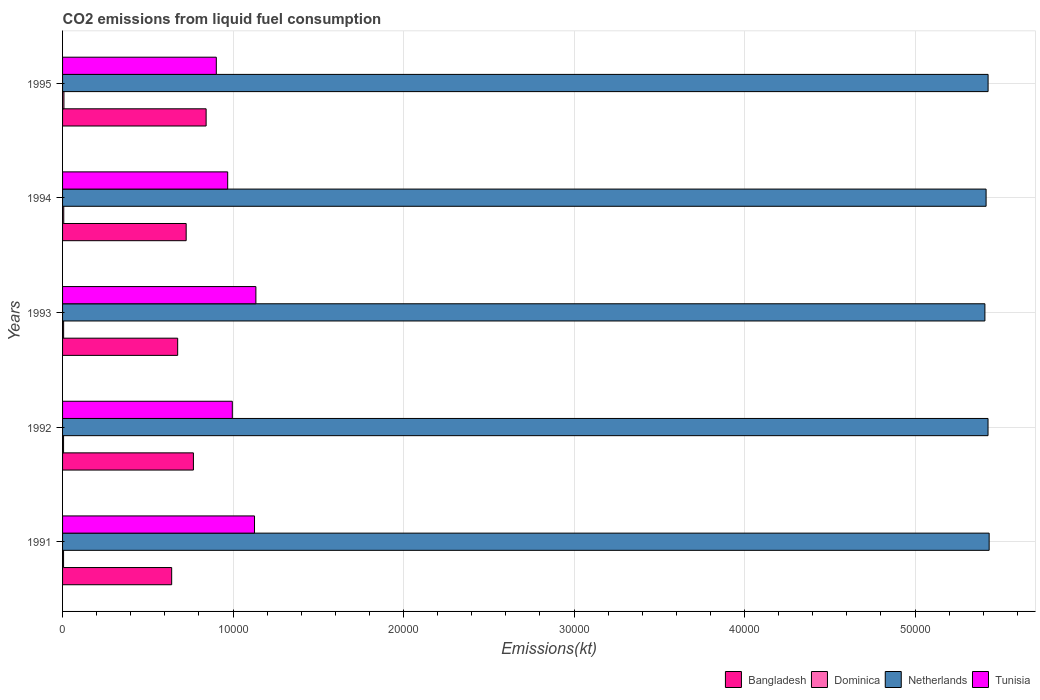How many different coloured bars are there?
Offer a very short reply. 4. Are the number of bars on each tick of the Y-axis equal?
Provide a succinct answer. Yes. What is the label of the 1st group of bars from the top?
Offer a terse response. 1995. What is the amount of CO2 emitted in Netherlands in 1992?
Your answer should be compact. 5.43e+04. Across all years, what is the maximum amount of CO2 emitted in Bangladesh?
Provide a succinct answer. 8419.43. Across all years, what is the minimum amount of CO2 emitted in Bangladesh?
Make the answer very short. 6398.91. What is the total amount of CO2 emitted in Dominica in the graph?
Provide a short and direct response. 330.03. What is the difference between the amount of CO2 emitted in Netherlands in 1991 and that in 1993?
Your answer should be compact. 249.36. What is the difference between the amount of CO2 emitted in Netherlands in 1994 and the amount of CO2 emitted in Tunisia in 1993?
Your answer should be very brief. 4.28e+04. What is the average amount of CO2 emitted in Netherlands per year?
Make the answer very short. 5.42e+04. In the year 1993, what is the difference between the amount of CO2 emitted in Bangladesh and amount of CO2 emitted in Netherlands?
Make the answer very short. -4.73e+04. In how many years, is the amount of CO2 emitted in Dominica greater than 4000 kt?
Ensure brevity in your answer.  0. What is the ratio of the amount of CO2 emitted in Tunisia in 1992 to that in 1995?
Provide a short and direct response. 1.1. Is the amount of CO2 emitted in Netherlands in 1993 less than that in 1994?
Your answer should be very brief. Yes. Is the difference between the amount of CO2 emitted in Bangladesh in 1993 and 1994 greater than the difference between the amount of CO2 emitted in Netherlands in 1993 and 1994?
Your answer should be very brief. No. What is the difference between the highest and the second highest amount of CO2 emitted in Dominica?
Provide a short and direct response. 11. What is the difference between the highest and the lowest amount of CO2 emitted in Bangladesh?
Ensure brevity in your answer.  2020.52. Is it the case that in every year, the sum of the amount of CO2 emitted in Bangladesh and amount of CO2 emitted in Tunisia is greater than the sum of amount of CO2 emitted in Dominica and amount of CO2 emitted in Netherlands?
Provide a short and direct response. No. What does the 2nd bar from the top in 1991 represents?
Offer a very short reply. Netherlands. What does the 2nd bar from the bottom in 1991 represents?
Make the answer very short. Dominica. Is it the case that in every year, the sum of the amount of CO2 emitted in Tunisia and amount of CO2 emitted in Netherlands is greater than the amount of CO2 emitted in Bangladesh?
Keep it short and to the point. Yes. How many bars are there?
Your answer should be compact. 20. How many years are there in the graph?
Your response must be concise. 5. Are the values on the major ticks of X-axis written in scientific E-notation?
Provide a succinct answer. No. Does the graph contain any zero values?
Your response must be concise. No. Where does the legend appear in the graph?
Make the answer very short. Bottom right. How are the legend labels stacked?
Offer a very short reply. Horizontal. What is the title of the graph?
Keep it short and to the point. CO2 emissions from liquid fuel consumption. Does "Timor-Leste" appear as one of the legend labels in the graph?
Keep it short and to the point. No. What is the label or title of the X-axis?
Make the answer very short. Emissions(kt). What is the Emissions(kt) of Bangladesh in 1991?
Offer a terse response. 6398.91. What is the Emissions(kt) of Dominica in 1991?
Your answer should be compact. 58.67. What is the Emissions(kt) of Netherlands in 1991?
Your response must be concise. 5.43e+04. What is the Emissions(kt) in Tunisia in 1991?
Offer a terse response. 1.13e+04. What is the Emissions(kt) in Bangladesh in 1992?
Keep it short and to the point. 7675.03. What is the Emissions(kt) in Dominica in 1992?
Your answer should be compact. 58.67. What is the Emissions(kt) in Netherlands in 1992?
Give a very brief answer. 5.43e+04. What is the Emissions(kt) of Tunisia in 1992?
Make the answer very short. 9955.91. What is the Emissions(kt) in Bangladesh in 1993?
Ensure brevity in your answer.  6750.95. What is the Emissions(kt) of Dominica in 1993?
Provide a succinct answer. 62.34. What is the Emissions(kt) in Netherlands in 1993?
Offer a very short reply. 5.41e+04. What is the Emissions(kt) of Tunisia in 1993?
Your answer should be compact. 1.13e+04. What is the Emissions(kt) in Bangladesh in 1994?
Your answer should be compact. 7249.66. What is the Emissions(kt) in Dominica in 1994?
Your answer should be very brief. 69.67. What is the Emissions(kt) of Netherlands in 1994?
Give a very brief answer. 5.42e+04. What is the Emissions(kt) in Tunisia in 1994?
Ensure brevity in your answer.  9684.55. What is the Emissions(kt) in Bangladesh in 1995?
Give a very brief answer. 8419.43. What is the Emissions(kt) of Dominica in 1995?
Offer a terse response. 80.67. What is the Emissions(kt) in Netherlands in 1995?
Provide a short and direct response. 5.43e+04. What is the Emissions(kt) in Tunisia in 1995?
Offer a terse response. 9017.15. Across all years, what is the maximum Emissions(kt) of Bangladesh?
Ensure brevity in your answer.  8419.43. Across all years, what is the maximum Emissions(kt) of Dominica?
Ensure brevity in your answer.  80.67. Across all years, what is the maximum Emissions(kt) in Netherlands?
Provide a short and direct response. 5.43e+04. Across all years, what is the maximum Emissions(kt) of Tunisia?
Your response must be concise. 1.13e+04. Across all years, what is the minimum Emissions(kt) in Bangladesh?
Provide a short and direct response. 6398.91. Across all years, what is the minimum Emissions(kt) in Dominica?
Your response must be concise. 58.67. Across all years, what is the minimum Emissions(kt) in Netherlands?
Provide a succinct answer. 5.41e+04. Across all years, what is the minimum Emissions(kt) in Tunisia?
Your response must be concise. 9017.15. What is the total Emissions(kt) in Bangladesh in the graph?
Offer a very short reply. 3.65e+04. What is the total Emissions(kt) in Dominica in the graph?
Offer a terse response. 330.03. What is the total Emissions(kt) of Netherlands in the graph?
Provide a succinct answer. 2.71e+05. What is the total Emissions(kt) of Tunisia in the graph?
Your response must be concise. 5.13e+04. What is the difference between the Emissions(kt) in Bangladesh in 1991 and that in 1992?
Keep it short and to the point. -1276.12. What is the difference between the Emissions(kt) of Dominica in 1991 and that in 1992?
Ensure brevity in your answer.  0. What is the difference between the Emissions(kt) of Netherlands in 1991 and that in 1992?
Your response must be concise. 66.01. What is the difference between the Emissions(kt) of Tunisia in 1991 and that in 1992?
Make the answer very short. 1301.79. What is the difference between the Emissions(kt) in Bangladesh in 1991 and that in 1993?
Your answer should be compact. -352.03. What is the difference between the Emissions(kt) of Dominica in 1991 and that in 1993?
Provide a short and direct response. -3.67. What is the difference between the Emissions(kt) of Netherlands in 1991 and that in 1993?
Ensure brevity in your answer.  249.36. What is the difference between the Emissions(kt) in Tunisia in 1991 and that in 1993?
Keep it short and to the point. -80.67. What is the difference between the Emissions(kt) in Bangladesh in 1991 and that in 1994?
Offer a terse response. -850.74. What is the difference between the Emissions(kt) in Dominica in 1991 and that in 1994?
Offer a terse response. -11. What is the difference between the Emissions(kt) of Netherlands in 1991 and that in 1994?
Ensure brevity in your answer.  179.68. What is the difference between the Emissions(kt) of Tunisia in 1991 and that in 1994?
Give a very brief answer. 1573.14. What is the difference between the Emissions(kt) in Bangladesh in 1991 and that in 1995?
Offer a very short reply. -2020.52. What is the difference between the Emissions(kt) in Dominica in 1991 and that in 1995?
Offer a very short reply. -22. What is the difference between the Emissions(kt) in Netherlands in 1991 and that in 1995?
Give a very brief answer. 62.34. What is the difference between the Emissions(kt) in Tunisia in 1991 and that in 1995?
Offer a very short reply. 2240.54. What is the difference between the Emissions(kt) in Bangladesh in 1992 and that in 1993?
Your answer should be very brief. 924.08. What is the difference between the Emissions(kt) of Dominica in 1992 and that in 1993?
Your answer should be compact. -3.67. What is the difference between the Emissions(kt) of Netherlands in 1992 and that in 1993?
Ensure brevity in your answer.  183.35. What is the difference between the Emissions(kt) in Tunisia in 1992 and that in 1993?
Offer a very short reply. -1382.46. What is the difference between the Emissions(kt) in Bangladesh in 1992 and that in 1994?
Provide a short and direct response. 425.37. What is the difference between the Emissions(kt) of Dominica in 1992 and that in 1994?
Make the answer very short. -11. What is the difference between the Emissions(kt) in Netherlands in 1992 and that in 1994?
Offer a very short reply. 113.68. What is the difference between the Emissions(kt) of Tunisia in 1992 and that in 1994?
Provide a succinct answer. 271.36. What is the difference between the Emissions(kt) of Bangladesh in 1992 and that in 1995?
Your response must be concise. -744.4. What is the difference between the Emissions(kt) of Dominica in 1992 and that in 1995?
Keep it short and to the point. -22. What is the difference between the Emissions(kt) in Netherlands in 1992 and that in 1995?
Give a very brief answer. -3.67. What is the difference between the Emissions(kt) of Tunisia in 1992 and that in 1995?
Your response must be concise. 938.75. What is the difference between the Emissions(kt) of Bangladesh in 1993 and that in 1994?
Your answer should be compact. -498.71. What is the difference between the Emissions(kt) in Dominica in 1993 and that in 1994?
Give a very brief answer. -7.33. What is the difference between the Emissions(kt) of Netherlands in 1993 and that in 1994?
Ensure brevity in your answer.  -69.67. What is the difference between the Emissions(kt) of Tunisia in 1993 and that in 1994?
Ensure brevity in your answer.  1653.82. What is the difference between the Emissions(kt) in Bangladesh in 1993 and that in 1995?
Provide a short and direct response. -1668.48. What is the difference between the Emissions(kt) in Dominica in 1993 and that in 1995?
Ensure brevity in your answer.  -18.34. What is the difference between the Emissions(kt) of Netherlands in 1993 and that in 1995?
Your response must be concise. -187.02. What is the difference between the Emissions(kt) of Tunisia in 1993 and that in 1995?
Offer a very short reply. 2321.21. What is the difference between the Emissions(kt) of Bangladesh in 1994 and that in 1995?
Make the answer very short. -1169.77. What is the difference between the Emissions(kt) in Dominica in 1994 and that in 1995?
Offer a terse response. -11. What is the difference between the Emissions(kt) of Netherlands in 1994 and that in 1995?
Your response must be concise. -117.34. What is the difference between the Emissions(kt) of Tunisia in 1994 and that in 1995?
Ensure brevity in your answer.  667.39. What is the difference between the Emissions(kt) of Bangladesh in 1991 and the Emissions(kt) of Dominica in 1992?
Your response must be concise. 6340.24. What is the difference between the Emissions(kt) of Bangladesh in 1991 and the Emissions(kt) of Netherlands in 1992?
Your answer should be very brief. -4.79e+04. What is the difference between the Emissions(kt) of Bangladesh in 1991 and the Emissions(kt) of Tunisia in 1992?
Your response must be concise. -3556.99. What is the difference between the Emissions(kt) in Dominica in 1991 and the Emissions(kt) in Netherlands in 1992?
Provide a short and direct response. -5.42e+04. What is the difference between the Emissions(kt) of Dominica in 1991 and the Emissions(kt) of Tunisia in 1992?
Keep it short and to the point. -9897.23. What is the difference between the Emissions(kt) of Netherlands in 1991 and the Emissions(kt) of Tunisia in 1992?
Ensure brevity in your answer.  4.44e+04. What is the difference between the Emissions(kt) of Bangladesh in 1991 and the Emissions(kt) of Dominica in 1993?
Give a very brief answer. 6336.58. What is the difference between the Emissions(kt) of Bangladesh in 1991 and the Emissions(kt) of Netherlands in 1993?
Make the answer very short. -4.77e+04. What is the difference between the Emissions(kt) of Bangladesh in 1991 and the Emissions(kt) of Tunisia in 1993?
Keep it short and to the point. -4939.45. What is the difference between the Emissions(kt) in Dominica in 1991 and the Emissions(kt) in Netherlands in 1993?
Ensure brevity in your answer.  -5.40e+04. What is the difference between the Emissions(kt) of Dominica in 1991 and the Emissions(kt) of Tunisia in 1993?
Provide a short and direct response. -1.13e+04. What is the difference between the Emissions(kt) of Netherlands in 1991 and the Emissions(kt) of Tunisia in 1993?
Make the answer very short. 4.30e+04. What is the difference between the Emissions(kt) of Bangladesh in 1991 and the Emissions(kt) of Dominica in 1994?
Your response must be concise. 6329.24. What is the difference between the Emissions(kt) in Bangladesh in 1991 and the Emissions(kt) in Netherlands in 1994?
Make the answer very short. -4.78e+04. What is the difference between the Emissions(kt) of Bangladesh in 1991 and the Emissions(kt) of Tunisia in 1994?
Your response must be concise. -3285.63. What is the difference between the Emissions(kt) in Dominica in 1991 and the Emissions(kt) in Netherlands in 1994?
Offer a terse response. -5.41e+04. What is the difference between the Emissions(kt) in Dominica in 1991 and the Emissions(kt) in Tunisia in 1994?
Offer a very short reply. -9625.88. What is the difference between the Emissions(kt) of Netherlands in 1991 and the Emissions(kt) of Tunisia in 1994?
Give a very brief answer. 4.47e+04. What is the difference between the Emissions(kt) of Bangladesh in 1991 and the Emissions(kt) of Dominica in 1995?
Keep it short and to the point. 6318.24. What is the difference between the Emissions(kt) of Bangladesh in 1991 and the Emissions(kt) of Netherlands in 1995?
Your response must be concise. -4.79e+04. What is the difference between the Emissions(kt) in Bangladesh in 1991 and the Emissions(kt) in Tunisia in 1995?
Give a very brief answer. -2618.24. What is the difference between the Emissions(kt) in Dominica in 1991 and the Emissions(kt) in Netherlands in 1995?
Keep it short and to the point. -5.42e+04. What is the difference between the Emissions(kt) of Dominica in 1991 and the Emissions(kt) of Tunisia in 1995?
Offer a terse response. -8958.48. What is the difference between the Emissions(kt) of Netherlands in 1991 and the Emissions(kt) of Tunisia in 1995?
Give a very brief answer. 4.53e+04. What is the difference between the Emissions(kt) of Bangladesh in 1992 and the Emissions(kt) of Dominica in 1993?
Ensure brevity in your answer.  7612.69. What is the difference between the Emissions(kt) in Bangladesh in 1992 and the Emissions(kt) in Netherlands in 1993?
Give a very brief answer. -4.64e+04. What is the difference between the Emissions(kt) of Bangladesh in 1992 and the Emissions(kt) of Tunisia in 1993?
Give a very brief answer. -3663.33. What is the difference between the Emissions(kt) in Dominica in 1992 and the Emissions(kt) in Netherlands in 1993?
Your answer should be compact. -5.40e+04. What is the difference between the Emissions(kt) in Dominica in 1992 and the Emissions(kt) in Tunisia in 1993?
Keep it short and to the point. -1.13e+04. What is the difference between the Emissions(kt) in Netherlands in 1992 and the Emissions(kt) in Tunisia in 1993?
Your answer should be very brief. 4.29e+04. What is the difference between the Emissions(kt) of Bangladesh in 1992 and the Emissions(kt) of Dominica in 1994?
Provide a succinct answer. 7605.36. What is the difference between the Emissions(kt) of Bangladesh in 1992 and the Emissions(kt) of Netherlands in 1994?
Your response must be concise. -4.65e+04. What is the difference between the Emissions(kt) in Bangladesh in 1992 and the Emissions(kt) in Tunisia in 1994?
Your answer should be compact. -2009.52. What is the difference between the Emissions(kt) in Dominica in 1992 and the Emissions(kt) in Netherlands in 1994?
Give a very brief answer. -5.41e+04. What is the difference between the Emissions(kt) of Dominica in 1992 and the Emissions(kt) of Tunisia in 1994?
Offer a terse response. -9625.88. What is the difference between the Emissions(kt) of Netherlands in 1992 and the Emissions(kt) of Tunisia in 1994?
Offer a very short reply. 4.46e+04. What is the difference between the Emissions(kt) of Bangladesh in 1992 and the Emissions(kt) of Dominica in 1995?
Your answer should be very brief. 7594.36. What is the difference between the Emissions(kt) in Bangladesh in 1992 and the Emissions(kt) in Netherlands in 1995?
Provide a succinct answer. -4.66e+04. What is the difference between the Emissions(kt) in Bangladesh in 1992 and the Emissions(kt) in Tunisia in 1995?
Your response must be concise. -1342.12. What is the difference between the Emissions(kt) in Dominica in 1992 and the Emissions(kt) in Netherlands in 1995?
Your answer should be very brief. -5.42e+04. What is the difference between the Emissions(kt) in Dominica in 1992 and the Emissions(kt) in Tunisia in 1995?
Ensure brevity in your answer.  -8958.48. What is the difference between the Emissions(kt) of Netherlands in 1992 and the Emissions(kt) of Tunisia in 1995?
Provide a succinct answer. 4.53e+04. What is the difference between the Emissions(kt) in Bangladesh in 1993 and the Emissions(kt) in Dominica in 1994?
Give a very brief answer. 6681.27. What is the difference between the Emissions(kt) in Bangladesh in 1993 and the Emissions(kt) in Netherlands in 1994?
Keep it short and to the point. -4.74e+04. What is the difference between the Emissions(kt) in Bangladesh in 1993 and the Emissions(kt) in Tunisia in 1994?
Offer a very short reply. -2933.6. What is the difference between the Emissions(kt) in Dominica in 1993 and the Emissions(kt) in Netherlands in 1994?
Provide a succinct answer. -5.41e+04. What is the difference between the Emissions(kt) of Dominica in 1993 and the Emissions(kt) of Tunisia in 1994?
Offer a very short reply. -9622.21. What is the difference between the Emissions(kt) in Netherlands in 1993 and the Emissions(kt) in Tunisia in 1994?
Offer a very short reply. 4.44e+04. What is the difference between the Emissions(kt) of Bangladesh in 1993 and the Emissions(kt) of Dominica in 1995?
Provide a short and direct response. 6670.27. What is the difference between the Emissions(kt) of Bangladesh in 1993 and the Emissions(kt) of Netherlands in 1995?
Your response must be concise. -4.75e+04. What is the difference between the Emissions(kt) in Bangladesh in 1993 and the Emissions(kt) in Tunisia in 1995?
Provide a succinct answer. -2266.21. What is the difference between the Emissions(kt) in Dominica in 1993 and the Emissions(kt) in Netherlands in 1995?
Offer a terse response. -5.42e+04. What is the difference between the Emissions(kt) in Dominica in 1993 and the Emissions(kt) in Tunisia in 1995?
Give a very brief answer. -8954.81. What is the difference between the Emissions(kt) of Netherlands in 1993 and the Emissions(kt) of Tunisia in 1995?
Your answer should be compact. 4.51e+04. What is the difference between the Emissions(kt) in Bangladesh in 1994 and the Emissions(kt) in Dominica in 1995?
Provide a short and direct response. 7168.98. What is the difference between the Emissions(kt) of Bangladesh in 1994 and the Emissions(kt) of Netherlands in 1995?
Offer a terse response. -4.70e+04. What is the difference between the Emissions(kt) of Bangladesh in 1994 and the Emissions(kt) of Tunisia in 1995?
Keep it short and to the point. -1767.49. What is the difference between the Emissions(kt) in Dominica in 1994 and the Emissions(kt) in Netherlands in 1995?
Give a very brief answer. -5.42e+04. What is the difference between the Emissions(kt) of Dominica in 1994 and the Emissions(kt) of Tunisia in 1995?
Offer a terse response. -8947.48. What is the difference between the Emissions(kt) in Netherlands in 1994 and the Emissions(kt) in Tunisia in 1995?
Make the answer very short. 4.51e+04. What is the average Emissions(kt) of Bangladesh per year?
Give a very brief answer. 7298.8. What is the average Emissions(kt) in Dominica per year?
Give a very brief answer. 66.01. What is the average Emissions(kt) in Netherlands per year?
Ensure brevity in your answer.  5.42e+04. What is the average Emissions(kt) in Tunisia per year?
Give a very brief answer. 1.03e+04. In the year 1991, what is the difference between the Emissions(kt) in Bangladesh and Emissions(kt) in Dominica?
Offer a terse response. 6340.24. In the year 1991, what is the difference between the Emissions(kt) in Bangladesh and Emissions(kt) in Netherlands?
Ensure brevity in your answer.  -4.79e+04. In the year 1991, what is the difference between the Emissions(kt) of Bangladesh and Emissions(kt) of Tunisia?
Provide a succinct answer. -4858.77. In the year 1991, what is the difference between the Emissions(kt) of Dominica and Emissions(kt) of Netherlands?
Offer a very short reply. -5.43e+04. In the year 1991, what is the difference between the Emissions(kt) of Dominica and Emissions(kt) of Tunisia?
Provide a short and direct response. -1.12e+04. In the year 1991, what is the difference between the Emissions(kt) in Netherlands and Emissions(kt) in Tunisia?
Make the answer very short. 4.31e+04. In the year 1992, what is the difference between the Emissions(kt) of Bangladesh and Emissions(kt) of Dominica?
Ensure brevity in your answer.  7616.36. In the year 1992, what is the difference between the Emissions(kt) in Bangladesh and Emissions(kt) in Netherlands?
Provide a short and direct response. -4.66e+04. In the year 1992, what is the difference between the Emissions(kt) in Bangladesh and Emissions(kt) in Tunisia?
Provide a succinct answer. -2280.87. In the year 1992, what is the difference between the Emissions(kt) of Dominica and Emissions(kt) of Netherlands?
Make the answer very short. -5.42e+04. In the year 1992, what is the difference between the Emissions(kt) of Dominica and Emissions(kt) of Tunisia?
Ensure brevity in your answer.  -9897.23. In the year 1992, what is the difference between the Emissions(kt) in Netherlands and Emissions(kt) in Tunisia?
Make the answer very short. 4.43e+04. In the year 1993, what is the difference between the Emissions(kt) of Bangladesh and Emissions(kt) of Dominica?
Your answer should be very brief. 6688.61. In the year 1993, what is the difference between the Emissions(kt) in Bangladesh and Emissions(kt) in Netherlands?
Give a very brief answer. -4.73e+04. In the year 1993, what is the difference between the Emissions(kt) of Bangladesh and Emissions(kt) of Tunisia?
Make the answer very short. -4587.42. In the year 1993, what is the difference between the Emissions(kt) of Dominica and Emissions(kt) of Netherlands?
Offer a very short reply. -5.40e+04. In the year 1993, what is the difference between the Emissions(kt) of Dominica and Emissions(kt) of Tunisia?
Keep it short and to the point. -1.13e+04. In the year 1993, what is the difference between the Emissions(kt) of Netherlands and Emissions(kt) of Tunisia?
Offer a terse response. 4.28e+04. In the year 1994, what is the difference between the Emissions(kt) of Bangladesh and Emissions(kt) of Dominica?
Provide a short and direct response. 7179.99. In the year 1994, what is the difference between the Emissions(kt) in Bangladesh and Emissions(kt) in Netherlands?
Offer a terse response. -4.69e+04. In the year 1994, what is the difference between the Emissions(kt) of Bangladesh and Emissions(kt) of Tunisia?
Provide a succinct answer. -2434.89. In the year 1994, what is the difference between the Emissions(kt) in Dominica and Emissions(kt) in Netherlands?
Your answer should be very brief. -5.41e+04. In the year 1994, what is the difference between the Emissions(kt) of Dominica and Emissions(kt) of Tunisia?
Provide a succinct answer. -9614.87. In the year 1994, what is the difference between the Emissions(kt) in Netherlands and Emissions(kt) in Tunisia?
Your response must be concise. 4.45e+04. In the year 1995, what is the difference between the Emissions(kt) in Bangladesh and Emissions(kt) in Dominica?
Ensure brevity in your answer.  8338.76. In the year 1995, what is the difference between the Emissions(kt) of Bangladesh and Emissions(kt) of Netherlands?
Ensure brevity in your answer.  -4.59e+04. In the year 1995, what is the difference between the Emissions(kt) in Bangladesh and Emissions(kt) in Tunisia?
Keep it short and to the point. -597.72. In the year 1995, what is the difference between the Emissions(kt) in Dominica and Emissions(kt) in Netherlands?
Give a very brief answer. -5.42e+04. In the year 1995, what is the difference between the Emissions(kt) of Dominica and Emissions(kt) of Tunisia?
Ensure brevity in your answer.  -8936.48. In the year 1995, what is the difference between the Emissions(kt) of Netherlands and Emissions(kt) of Tunisia?
Offer a terse response. 4.53e+04. What is the ratio of the Emissions(kt) in Bangladesh in 1991 to that in 1992?
Keep it short and to the point. 0.83. What is the ratio of the Emissions(kt) of Dominica in 1991 to that in 1992?
Make the answer very short. 1. What is the ratio of the Emissions(kt) in Netherlands in 1991 to that in 1992?
Offer a terse response. 1. What is the ratio of the Emissions(kt) in Tunisia in 1991 to that in 1992?
Offer a very short reply. 1.13. What is the ratio of the Emissions(kt) in Bangladesh in 1991 to that in 1993?
Give a very brief answer. 0.95. What is the ratio of the Emissions(kt) of Dominica in 1991 to that in 1993?
Make the answer very short. 0.94. What is the ratio of the Emissions(kt) in Tunisia in 1991 to that in 1993?
Offer a very short reply. 0.99. What is the ratio of the Emissions(kt) of Bangladesh in 1991 to that in 1994?
Offer a terse response. 0.88. What is the ratio of the Emissions(kt) in Dominica in 1991 to that in 1994?
Your response must be concise. 0.84. What is the ratio of the Emissions(kt) of Netherlands in 1991 to that in 1994?
Offer a terse response. 1. What is the ratio of the Emissions(kt) in Tunisia in 1991 to that in 1994?
Provide a short and direct response. 1.16. What is the ratio of the Emissions(kt) in Bangladesh in 1991 to that in 1995?
Your response must be concise. 0.76. What is the ratio of the Emissions(kt) of Dominica in 1991 to that in 1995?
Provide a short and direct response. 0.73. What is the ratio of the Emissions(kt) of Tunisia in 1991 to that in 1995?
Your answer should be compact. 1.25. What is the ratio of the Emissions(kt) of Bangladesh in 1992 to that in 1993?
Offer a very short reply. 1.14. What is the ratio of the Emissions(kt) in Netherlands in 1992 to that in 1993?
Offer a terse response. 1. What is the ratio of the Emissions(kt) of Tunisia in 1992 to that in 1993?
Your answer should be compact. 0.88. What is the ratio of the Emissions(kt) of Bangladesh in 1992 to that in 1994?
Provide a short and direct response. 1.06. What is the ratio of the Emissions(kt) of Dominica in 1992 to that in 1994?
Give a very brief answer. 0.84. What is the ratio of the Emissions(kt) in Netherlands in 1992 to that in 1994?
Keep it short and to the point. 1. What is the ratio of the Emissions(kt) in Tunisia in 1992 to that in 1994?
Your answer should be compact. 1.03. What is the ratio of the Emissions(kt) of Bangladesh in 1992 to that in 1995?
Offer a terse response. 0.91. What is the ratio of the Emissions(kt) of Dominica in 1992 to that in 1995?
Provide a short and direct response. 0.73. What is the ratio of the Emissions(kt) of Netherlands in 1992 to that in 1995?
Your answer should be very brief. 1. What is the ratio of the Emissions(kt) of Tunisia in 1992 to that in 1995?
Your answer should be compact. 1.1. What is the ratio of the Emissions(kt) of Bangladesh in 1993 to that in 1994?
Offer a very short reply. 0.93. What is the ratio of the Emissions(kt) in Dominica in 1993 to that in 1994?
Your answer should be very brief. 0.89. What is the ratio of the Emissions(kt) of Tunisia in 1993 to that in 1994?
Offer a terse response. 1.17. What is the ratio of the Emissions(kt) in Bangladesh in 1993 to that in 1995?
Offer a terse response. 0.8. What is the ratio of the Emissions(kt) in Dominica in 1993 to that in 1995?
Ensure brevity in your answer.  0.77. What is the ratio of the Emissions(kt) of Tunisia in 1993 to that in 1995?
Make the answer very short. 1.26. What is the ratio of the Emissions(kt) in Bangladesh in 1994 to that in 1995?
Offer a very short reply. 0.86. What is the ratio of the Emissions(kt) in Dominica in 1994 to that in 1995?
Your response must be concise. 0.86. What is the ratio of the Emissions(kt) in Netherlands in 1994 to that in 1995?
Provide a short and direct response. 1. What is the ratio of the Emissions(kt) of Tunisia in 1994 to that in 1995?
Your answer should be compact. 1.07. What is the difference between the highest and the second highest Emissions(kt) in Bangladesh?
Offer a terse response. 744.4. What is the difference between the highest and the second highest Emissions(kt) in Dominica?
Your answer should be very brief. 11. What is the difference between the highest and the second highest Emissions(kt) of Netherlands?
Ensure brevity in your answer.  62.34. What is the difference between the highest and the second highest Emissions(kt) of Tunisia?
Offer a very short reply. 80.67. What is the difference between the highest and the lowest Emissions(kt) in Bangladesh?
Provide a short and direct response. 2020.52. What is the difference between the highest and the lowest Emissions(kt) of Dominica?
Provide a succinct answer. 22. What is the difference between the highest and the lowest Emissions(kt) in Netherlands?
Ensure brevity in your answer.  249.36. What is the difference between the highest and the lowest Emissions(kt) of Tunisia?
Provide a succinct answer. 2321.21. 